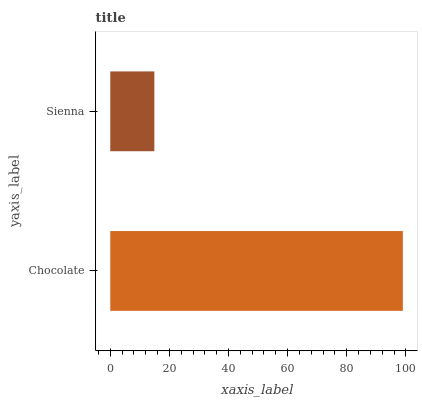Is Sienna the minimum?
Answer yes or no. Yes. Is Chocolate the maximum?
Answer yes or no. Yes. Is Sienna the maximum?
Answer yes or no. No. Is Chocolate greater than Sienna?
Answer yes or no. Yes. Is Sienna less than Chocolate?
Answer yes or no. Yes. Is Sienna greater than Chocolate?
Answer yes or no. No. Is Chocolate less than Sienna?
Answer yes or no. No. Is Chocolate the high median?
Answer yes or no. Yes. Is Sienna the low median?
Answer yes or no. Yes. Is Sienna the high median?
Answer yes or no. No. Is Chocolate the low median?
Answer yes or no. No. 